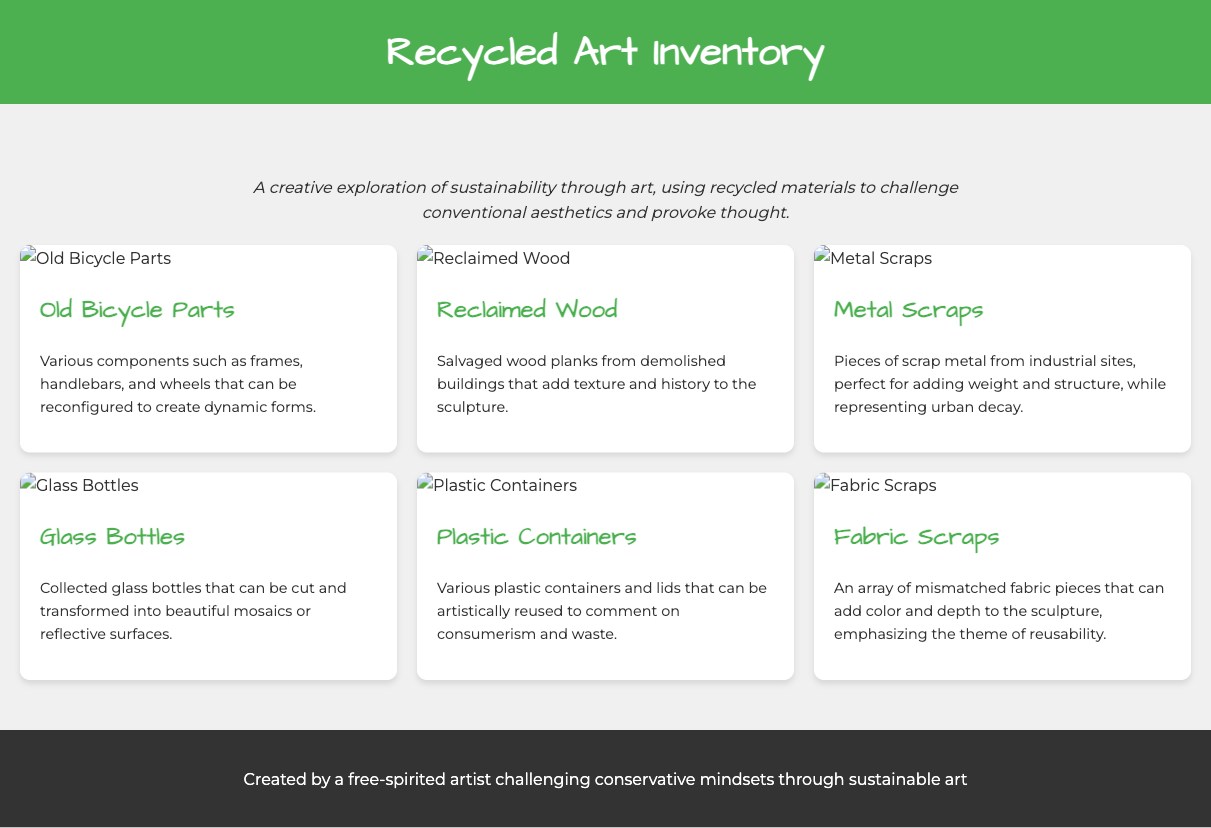what is the title of the document? The title of the document is stated in the header section, which is "Recycled Art Inventory."
Answer: Recycled Art Inventory how many different materials are listed? The document features a grid of six different materials, each represented by its own card.
Answer: six what is the first material mentioned? The first material card in the document displays "Old Bicycle Parts" as the material name.
Answer: Old Bicycle Parts which material is associated with urban decay? The document describes "Metal Scraps" as pieces of scrap metal representing urban decay.
Answer: Metal Scraps what type of materials does the document focus on? The document highlights materials that have been reused and recycled for artistic purposes, emphasizing sustainability.
Answer: recycled materials what image type is used for each material? Each material is accompanied by an image that visually represents it, utilizing a photograph format.
Answer: photographs which material can be transformed into mosaics? The document states that "Glass Bottles" can be cut and transformed into beautiful mosaics.
Answer: Glass Bottles how does the author describe reclaimed wood? Reclaimed wood is described in the document as salvaged wood planks that add texture and history.
Answer: salvaged wood planks what theme is emphasized in the fabric scraps? The theme emphasized in the fabric scraps material is reusability, adding color and depth to the sculpture.
Answer: reusability 